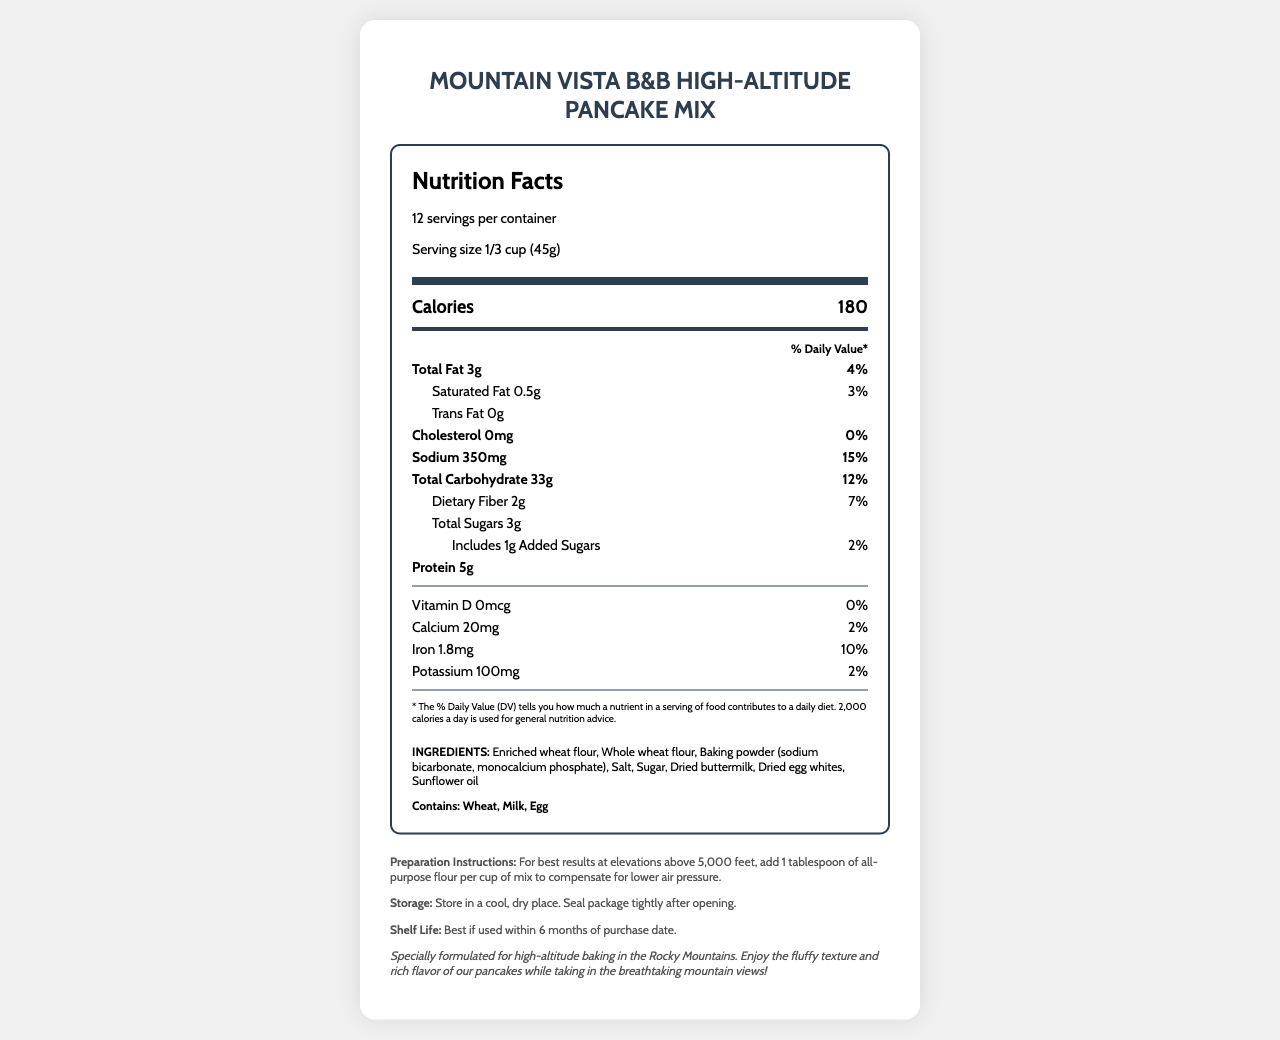what is the serving size? The serving size is stated in the serving information section of the nutrition facts label: "Serving size 1/3 cup (45g)."
Answer: 1/3 cup (45g) how many servings per container? The document mentions there are 12 servings per container in the serving information section.
Answer: 12 How much total fat is in each serving? The total fat content per serving is listed as 3g in the nutrient row section.
Answer: 3g what is the % daily value of Sodium? The sodium % daily value is given as 15% in the nutrient row for sodium.
Answer: 15% how much iron is in a serving? The amount of iron per serving is listed as 1.8mg in the nutrient row for iron.
Answer: 1.8mg Which of the following ingredients is not included in the pancake mix? A. Sunflower oil B. Almond milk C. Dried egg whites D. Baking powder The ingredient list includes Enriched wheat flour, Whole wheat flour, Baking powder (sodium bicarbonate, monocalcium phosphate), Salt, Sugar, Dried buttermilk, Dried egg whites, Sunflower oil.
Answer: B how many grams of dietary fiber are in one serving? The document lists 2g of dietary fiber in each serving in the nutrient row for dietary fiber.
Answer: 2g What are the preparation instructions for high-altitude? A. Add more water B. Decrease baking time C. Add 1 tablespoon of flour per cup of mix The preparation instructions specify to add 1 tablespoon of all-purpose flour per cup of mix to compensate for lower air pressure.
Answer: C Does the pancake mix contain allergens? The allergens section clearly states "Contains: Wheat, Milk, Egg."
Answer: Yes summarize the nutrition facts label for this pancake mix. This summary captures the essential details of the nutrition facts, ingredients, allergens, preparation instructions, storage, and shelf life provided for the pancake mix.
Answer: The Mountain Vista B&B High-Altitude Pancake Mix is designed for high-altitude baking, with a serving size of 1/3 cup (45g) and 12 servings per container. Each serving contains 180 calories, 3g of total fat, 0.5g of saturated fat, 0g of trans fat, 0mg of cholesterol, 350mg of sodium, 33g of total carbohydrate, 2g of dietary fiber, 3g of total sugars (including 1g of added sugars), and 5g of protein. It also provides small amounts of vitamin D, calcium, iron, and potassium. The ingredient list includes enriched and whole wheat flour, baking powder, salt, sugar, dried buttermilk, dried egg whites, and sunflower oil. Allergens include wheat, milk, and egg. Special instructions are provided for high-altitude preparation, and the mix should be stored in a cool, dry place and used within 6 months. how many calories are in one serving? Each serving has 180 calories as stated in the prominent calorie section of the nutrition facts label.
Answer: 180 What is the amount of added sugars per serving? The document lists the amount of added sugars per serving as 1g in the nutrient row.
Answer: 1g what is the best storage condition for this pancake mix? The storage instructions in the additional info section state to store the mix in a cool, dry place, and to seal the package tightly after opening.
Answer: Store in a cool, dry place. Seal package tightly after opening. What is the shelf life of this pancake mix? The shelf life is given as "Best if used within 6 months of purchase date" in the additional info section.
Answer: Best if used within 6 months of purchase date. Is there any trans fat in this pancake mix? A. Yes B. No The nutrition label states 0g of trans fat.
Answer: B what is the most common type of weather in the mountainous area? The document does not provide any information regarding weather patterns in the mountainous area.
Answer: Cannot be determined 